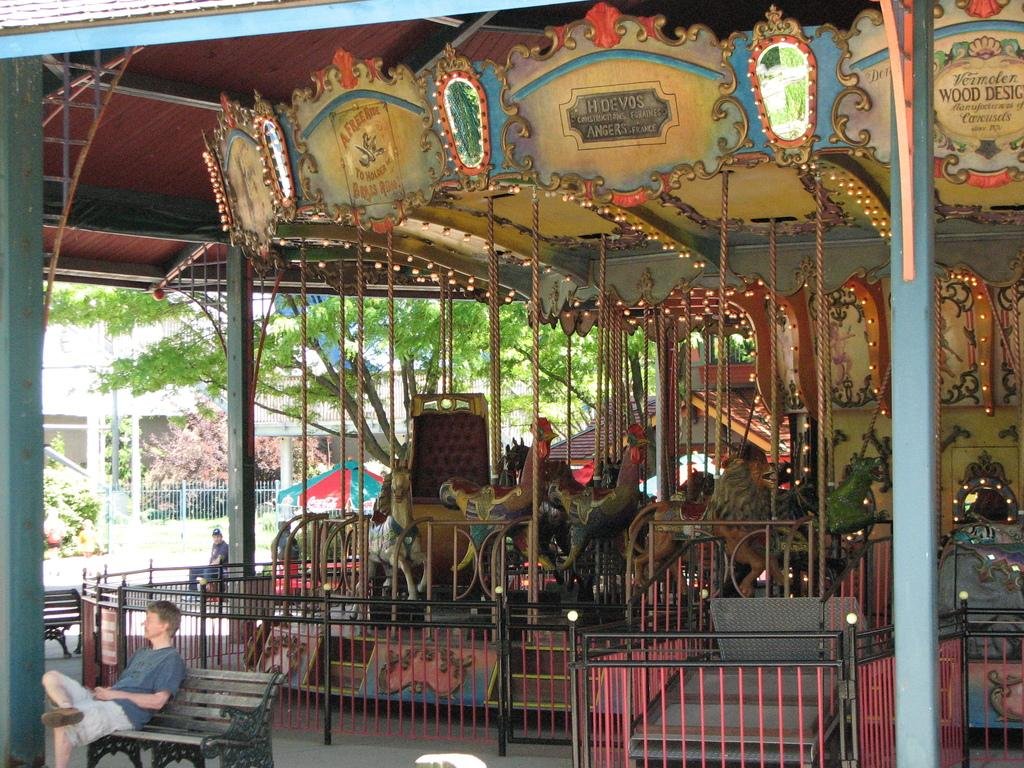What type of ride is in the image? There is a child carousel in the image. What are the people in the image doing? The people are sitting on benches in the image. What is the purpose of the fence in the image? The fence is present in the image, but its purpose is not explicitly stated. What type of vegetation is in the image? There are trees in the image. What type of structure is in the image? There is a building in the image. Where is the cannon located in the image? There is no cannon present in the image. What part of the carousel is not visible in the image? The image does not show any specific part of the carousel, so it is not possible to determine which part is not visible. 